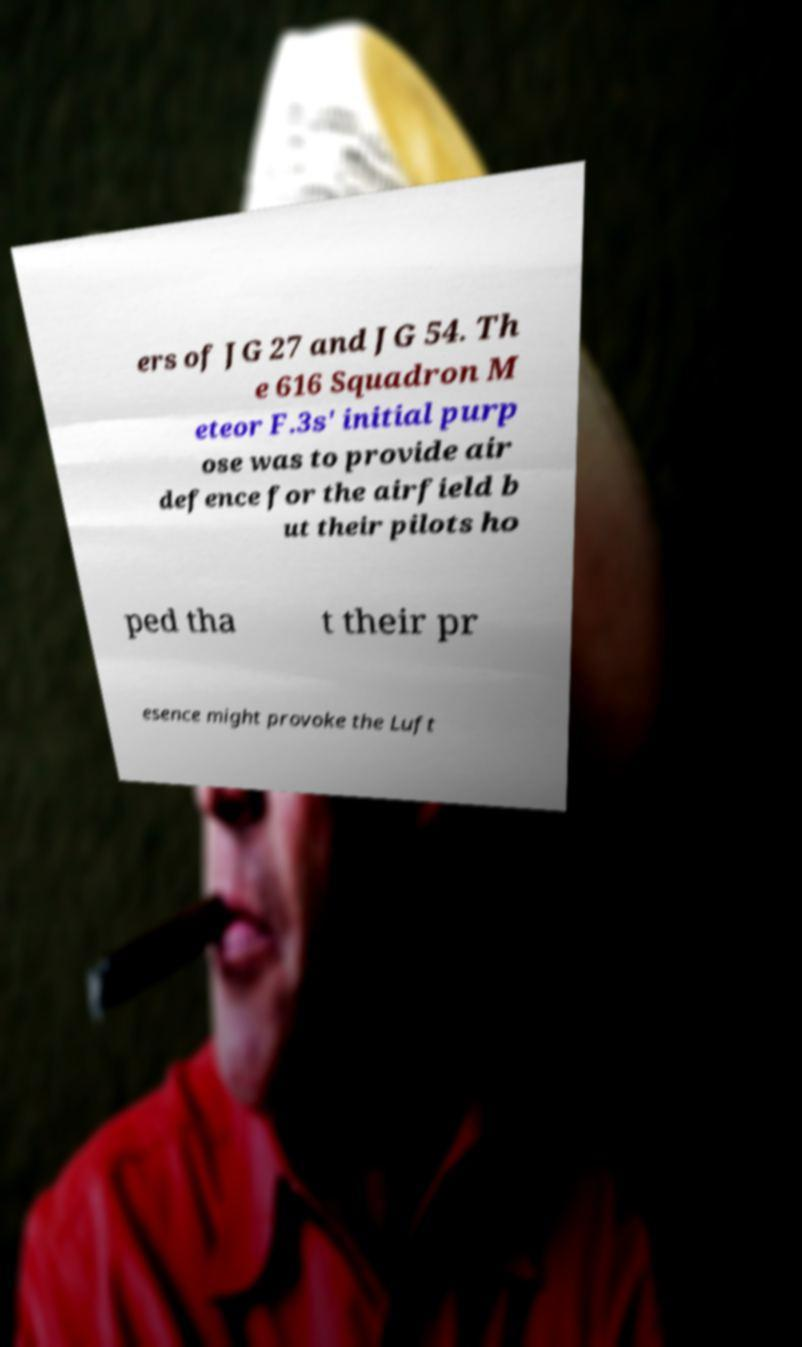Can you read and provide the text displayed in the image?This photo seems to have some interesting text. Can you extract and type it out for me? ers of JG 27 and JG 54. Th e 616 Squadron M eteor F.3s' initial purp ose was to provide air defence for the airfield b ut their pilots ho ped tha t their pr esence might provoke the Luft 